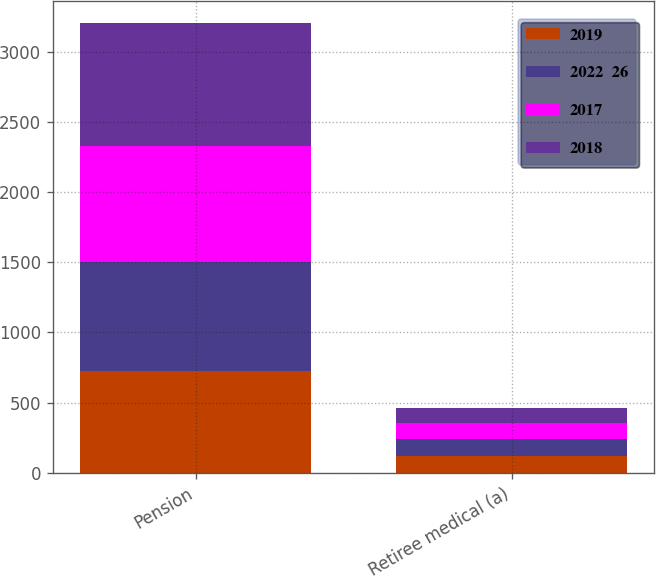Convert chart. <chart><loc_0><loc_0><loc_500><loc_500><stacked_bar_chart><ecel><fcel>Pension<fcel>Retiree medical (a)<nl><fcel>2019<fcel>725<fcel>120<nl><fcel>2022  26<fcel>780<fcel>120<nl><fcel>2017<fcel>825<fcel>115<nl><fcel>2018<fcel>870<fcel>110<nl></chart> 